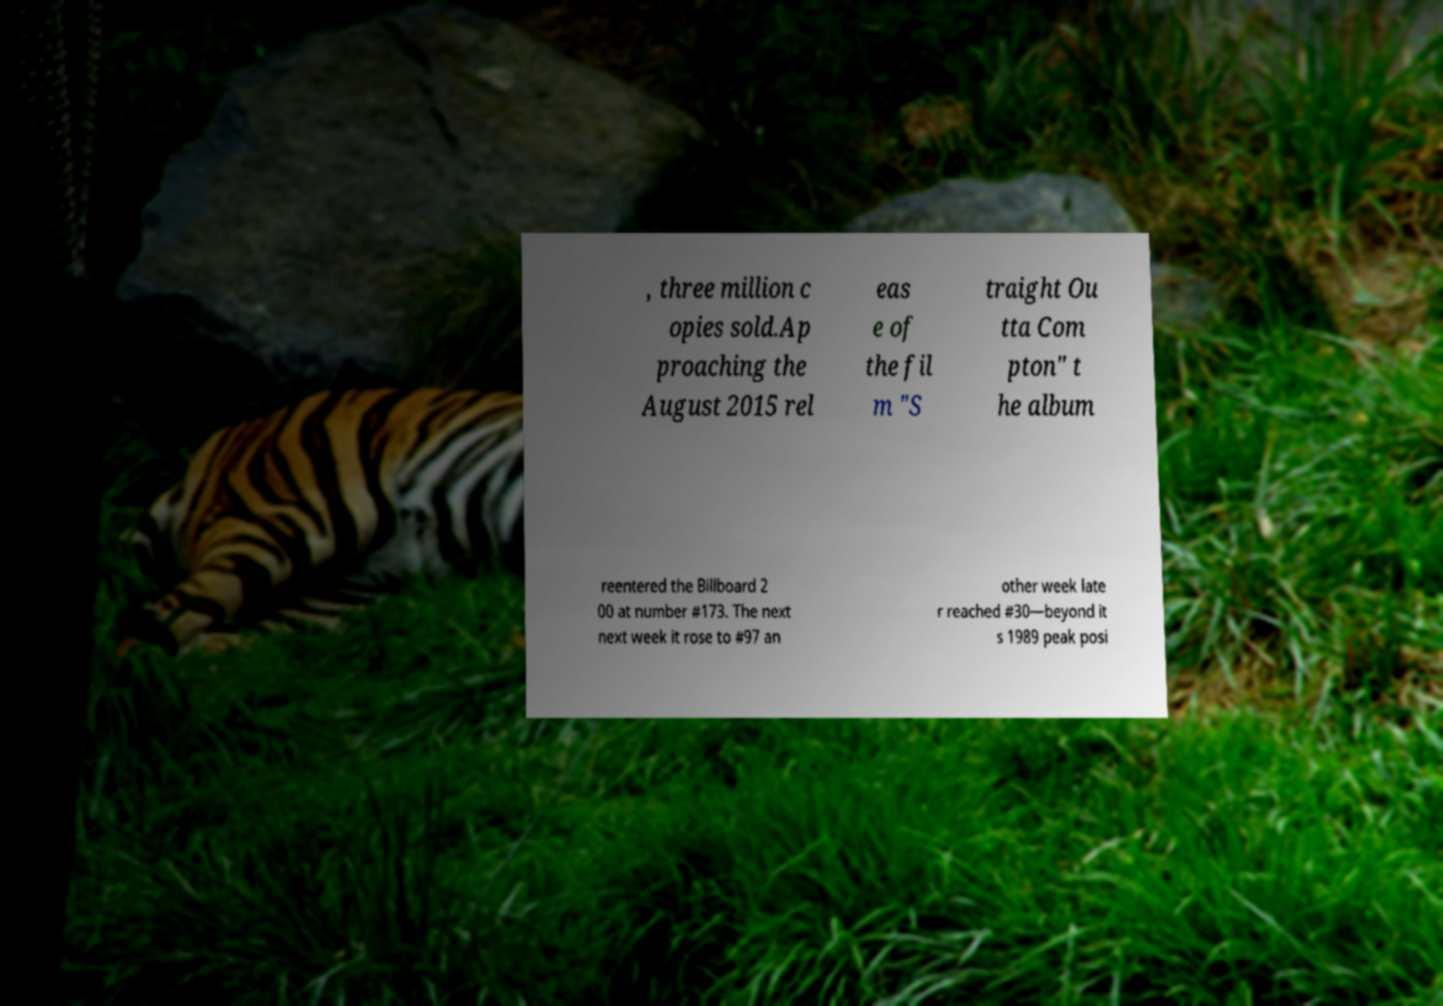There's text embedded in this image that I need extracted. Can you transcribe it verbatim? , three million c opies sold.Ap proaching the August 2015 rel eas e of the fil m "S traight Ou tta Com pton" t he album reentered the Billboard 2 00 at number #173. The next next week it rose to #97 an other week late r reached #30—beyond it s 1989 peak posi 